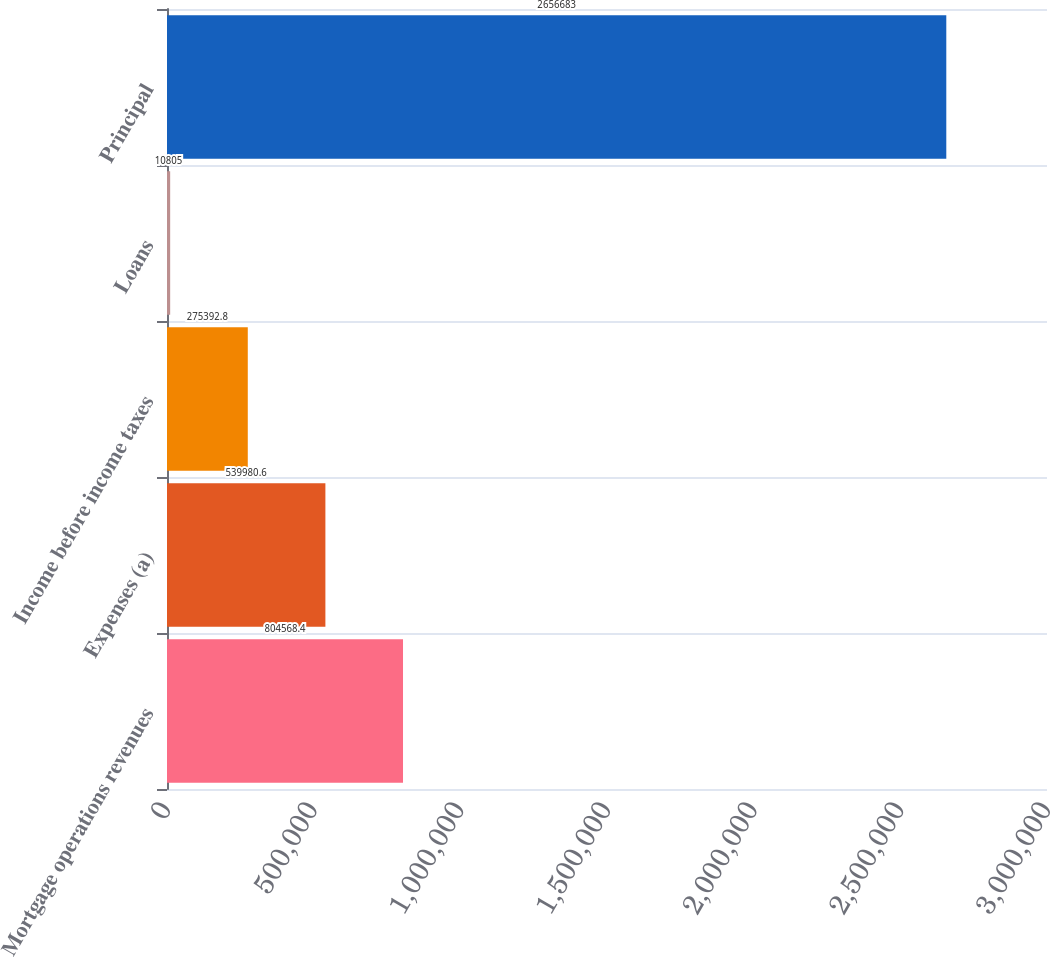Convert chart to OTSL. <chart><loc_0><loc_0><loc_500><loc_500><bar_chart><fcel>Mortgage operations revenues<fcel>Expenses (a)<fcel>Income before income taxes<fcel>Loans<fcel>Principal<nl><fcel>804568<fcel>539981<fcel>275393<fcel>10805<fcel>2.65668e+06<nl></chart> 